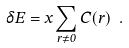<formula> <loc_0><loc_0><loc_500><loc_500>\delta E = x \sum _ { r \ne 0 } C ( r ) \ .</formula> 